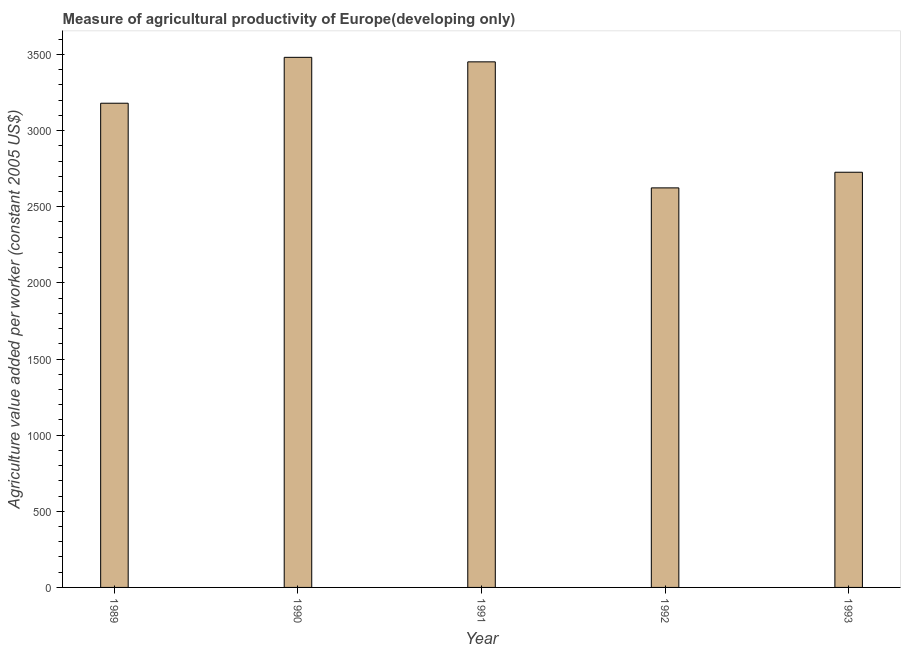Does the graph contain any zero values?
Provide a succinct answer. No. What is the title of the graph?
Your answer should be compact. Measure of agricultural productivity of Europe(developing only). What is the label or title of the Y-axis?
Keep it short and to the point. Agriculture value added per worker (constant 2005 US$). What is the agriculture value added per worker in 1989?
Provide a short and direct response. 3179.79. Across all years, what is the maximum agriculture value added per worker?
Offer a very short reply. 3481.2. Across all years, what is the minimum agriculture value added per worker?
Give a very brief answer. 2623.82. In which year was the agriculture value added per worker maximum?
Make the answer very short. 1990. What is the sum of the agriculture value added per worker?
Your answer should be very brief. 1.55e+04. What is the difference between the agriculture value added per worker in 1989 and 1990?
Offer a terse response. -301.4. What is the average agriculture value added per worker per year?
Offer a terse response. 3092.58. What is the median agriculture value added per worker?
Keep it short and to the point. 3179.79. In how many years, is the agriculture value added per worker greater than 400 US$?
Your answer should be very brief. 5. Do a majority of the years between 1990 and 1989 (inclusive) have agriculture value added per worker greater than 3300 US$?
Keep it short and to the point. No. Is the agriculture value added per worker in 1989 less than that in 1991?
Offer a terse response. Yes. Is the difference between the agriculture value added per worker in 1989 and 1993 greater than the difference between any two years?
Your response must be concise. No. What is the difference between the highest and the second highest agriculture value added per worker?
Ensure brevity in your answer.  29.65. Is the sum of the agriculture value added per worker in 1990 and 1991 greater than the maximum agriculture value added per worker across all years?
Your answer should be very brief. Yes. What is the difference between the highest and the lowest agriculture value added per worker?
Keep it short and to the point. 857.38. Are all the bars in the graph horizontal?
Your response must be concise. No. How many years are there in the graph?
Your answer should be compact. 5. What is the Agriculture value added per worker (constant 2005 US$) in 1989?
Your answer should be very brief. 3179.79. What is the Agriculture value added per worker (constant 2005 US$) of 1990?
Offer a terse response. 3481.2. What is the Agriculture value added per worker (constant 2005 US$) of 1991?
Keep it short and to the point. 3451.55. What is the Agriculture value added per worker (constant 2005 US$) of 1992?
Keep it short and to the point. 2623.82. What is the Agriculture value added per worker (constant 2005 US$) of 1993?
Provide a short and direct response. 2726.56. What is the difference between the Agriculture value added per worker (constant 2005 US$) in 1989 and 1990?
Make the answer very short. -301.4. What is the difference between the Agriculture value added per worker (constant 2005 US$) in 1989 and 1991?
Give a very brief answer. -271.75. What is the difference between the Agriculture value added per worker (constant 2005 US$) in 1989 and 1992?
Make the answer very short. 555.98. What is the difference between the Agriculture value added per worker (constant 2005 US$) in 1989 and 1993?
Provide a short and direct response. 453.23. What is the difference between the Agriculture value added per worker (constant 2005 US$) in 1990 and 1991?
Offer a terse response. 29.65. What is the difference between the Agriculture value added per worker (constant 2005 US$) in 1990 and 1992?
Your answer should be very brief. 857.38. What is the difference between the Agriculture value added per worker (constant 2005 US$) in 1990 and 1993?
Your response must be concise. 754.64. What is the difference between the Agriculture value added per worker (constant 2005 US$) in 1991 and 1992?
Give a very brief answer. 827.73. What is the difference between the Agriculture value added per worker (constant 2005 US$) in 1991 and 1993?
Provide a succinct answer. 724.99. What is the difference between the Agriculture value added per worker (constant 2005 US$) in 1992 and 1993?
Your response must be concise. -102.74. What is the ratio of the Agriculture value added per worker (constant 2005 US$) in 1989 to that in 1991?
Offer a terse response. 0.92. What is the ratio of the Agriculture value added per worker (constant 2005 US$) in 1989 to that in 1992?
Provide a succinct answer. 1.21. What is the ratio of the Agriculture value added per worker (constant 2005 US$) in 1989 to that in 1993?
Your answer should be very brief. 1.17. What is the ratio of the Agriculture value added per worker (constant 2005 US$) in 1990 to that in 1992?
Your answer should be compact. 1.33. What is the ratio of the Agriculture value added per worker (constant 2005 US$) in 1990 to that in 1993?
Your response must be concise. 1.28. What is the ratio of the Agriculture value added per worker (constant 2005 US$) in 1991 to that in 1992?
Provide a short and direct response. 1.31. What is the ratio of the Agriculture value added per worker (constant 2005 US$) in 1991 to that in 1993?
Provide a short and direct response. 1.27. 